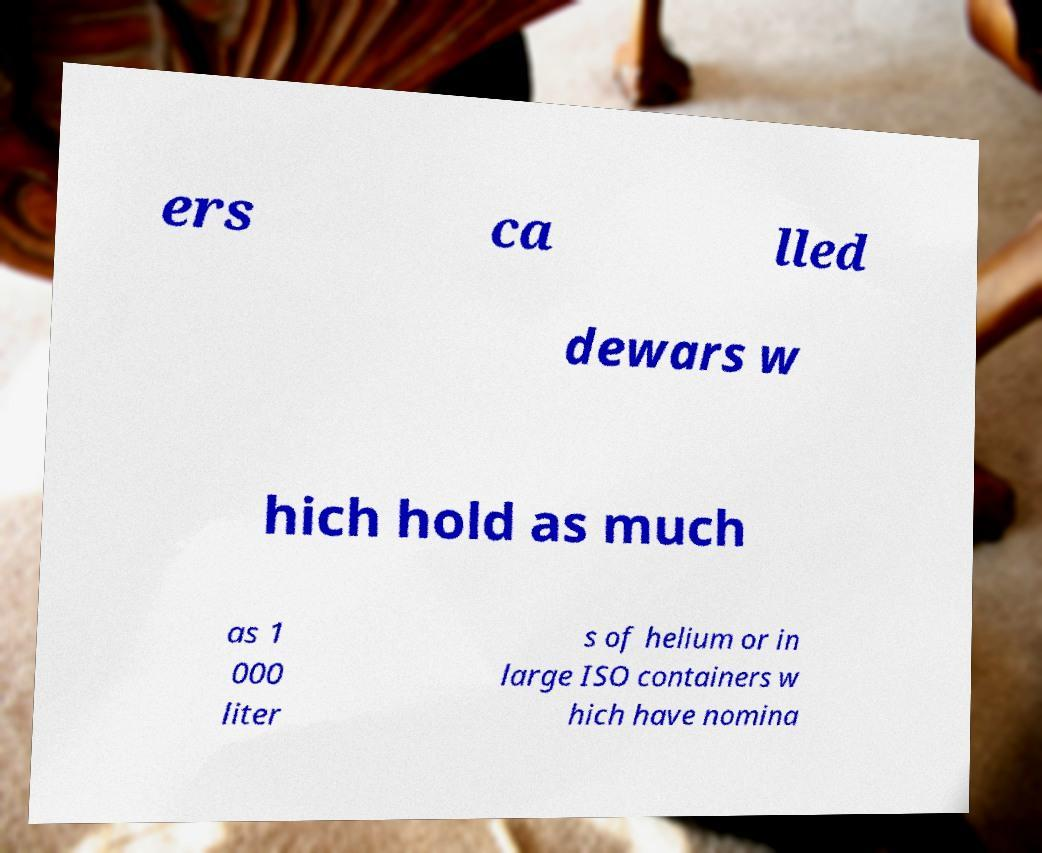Please read and relay the text visible in this image. What does it say? ers ca lled dewars w hich hold as much as 1 000 liter s of helium or in large ISO containers w hich have nomina 